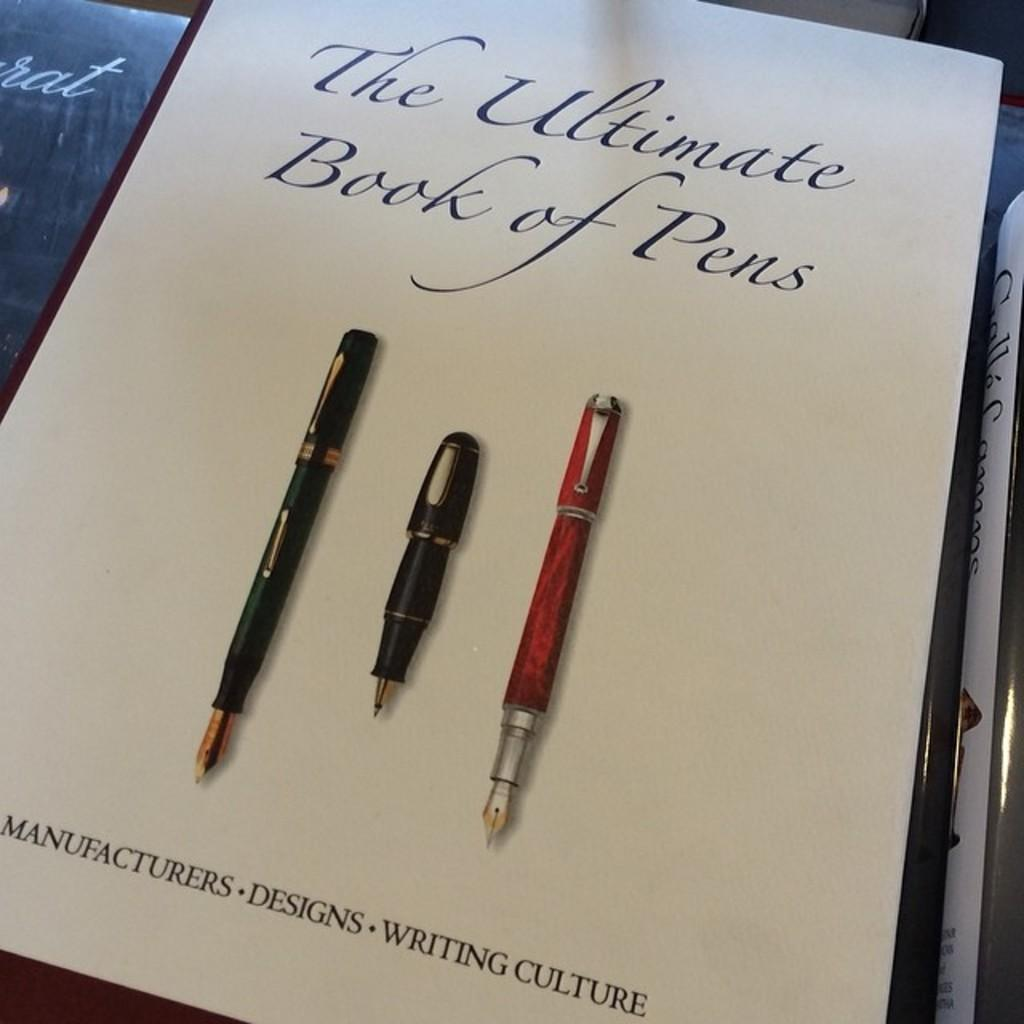What objects can be seen in the image? There are books in the image. What can be found on the book cover? The book cover has text on it and pictures of pens. What is the profit margin of the books in the image? There is no information about the profit margin of the books in the image, as it does not provide any details about the cost or value of the books. 